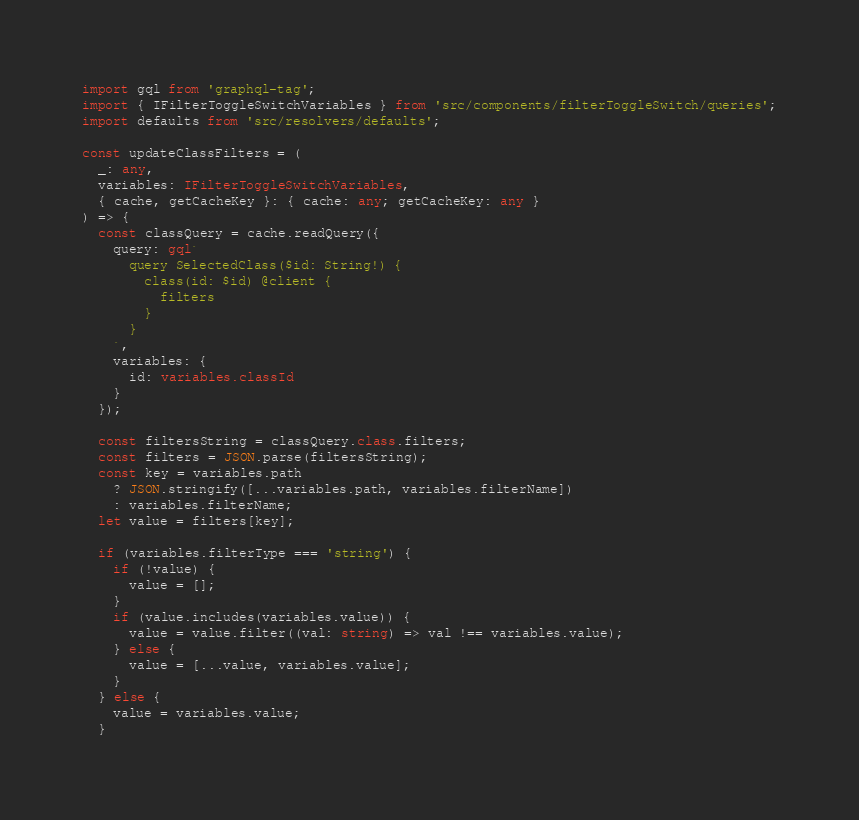<code> <loc_0><loc_0><loc_500><loc_500><_TypeScript_>import gql from 'graphql-tag';
import { IFilterToggleSwitchVariables } from 'src/components/filterToggleSwitch/queries';
import defaults from 'src/resolvers/defaults';

const updateClassFilters = (
  _: any,
  variables: IFilterToggleSwitchVariables,
  { cache, getCacheKey }: { cache: any; getCacheKey: any }
) => {
  const classQuery = cache.readQuery({
    query: gql`
      query SelectedClass($id: String!) {
        class(id: $id) @client {
          filters
        }
      }
    `,
    variables: {
      id: variables.classId
    }
  });

  const filtersString = classQuery.class.filters;
  const filters = JSON.parse(filtersString);
  const key = variables.path
    ? JSON.stringify([...variables.path, variables.filterName])
    : variables.filterName;
  let value = filters[key];

  if (variables.filterType === 'string') {
    if (!value) {
      value = [];
    }
    if (value.includes(variables.value)) {
      value = value.filter((val: string) => val !== variables.value);
    } else {
      value = [...value, variables.value];
    }
  } else {
    value = variables.value;
  }
</code> 